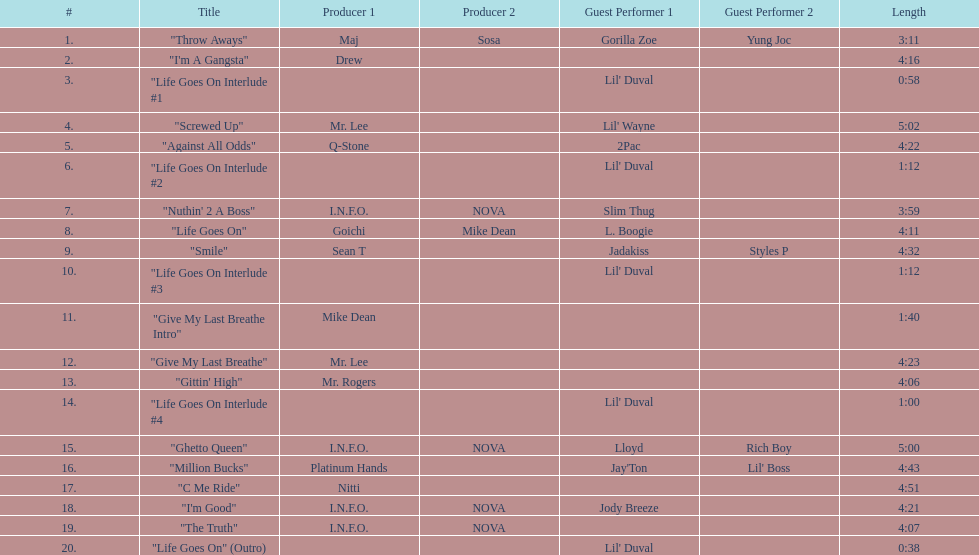What is the first track featuring lil' duval? "Life Goes On Interlude #1. 